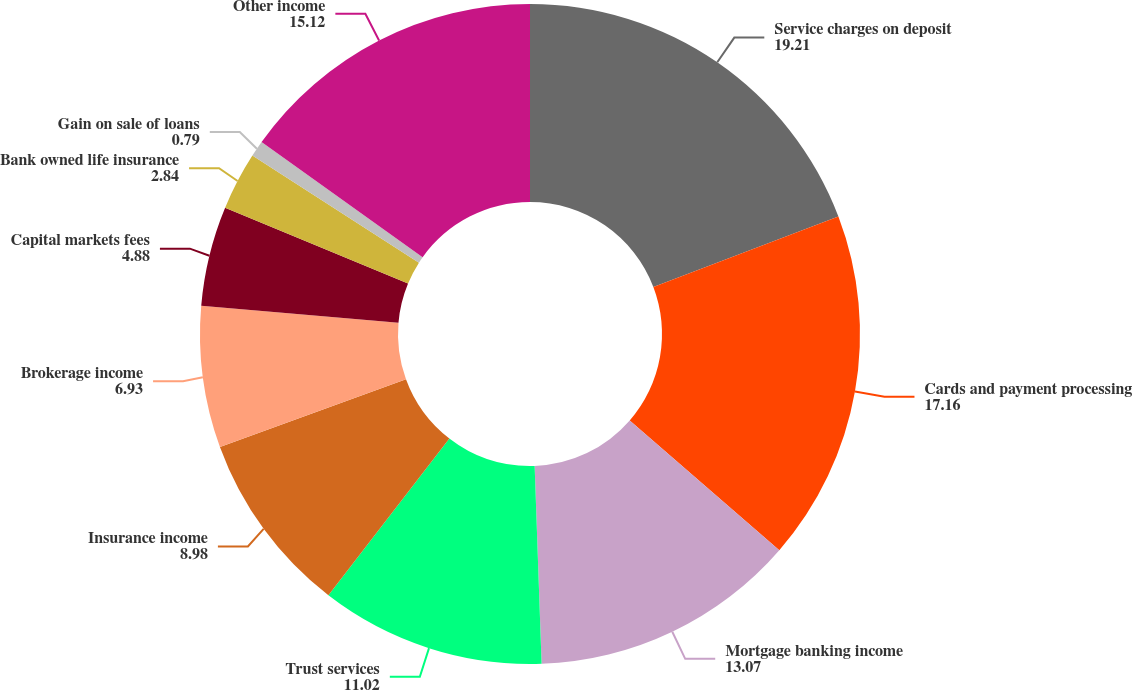Convert chart to OTSL. <chart><loc_0><loc_0><loc_500><loc_500><pie_chart><fcel>Service charges on deposit<fcel>Cards and payment processing<fcel>Mortgage banking income<fcel>Trust services<fcel>Insurance income<fcel>Brokerage income<fcel>Capital markets fees<fcel>Bank owned life insurance<fcel>Gain on sale of loans<fcel>Other income<nl><fcel>19.21%<fcel>17.16%<fcel>13.07%<fcel>11.02%<fcel>8.98%<fcel>6.93%<fcel>4.88%<fcel>2.84%<fcel>0.79%<fcel>15.12%<nl></chart> 